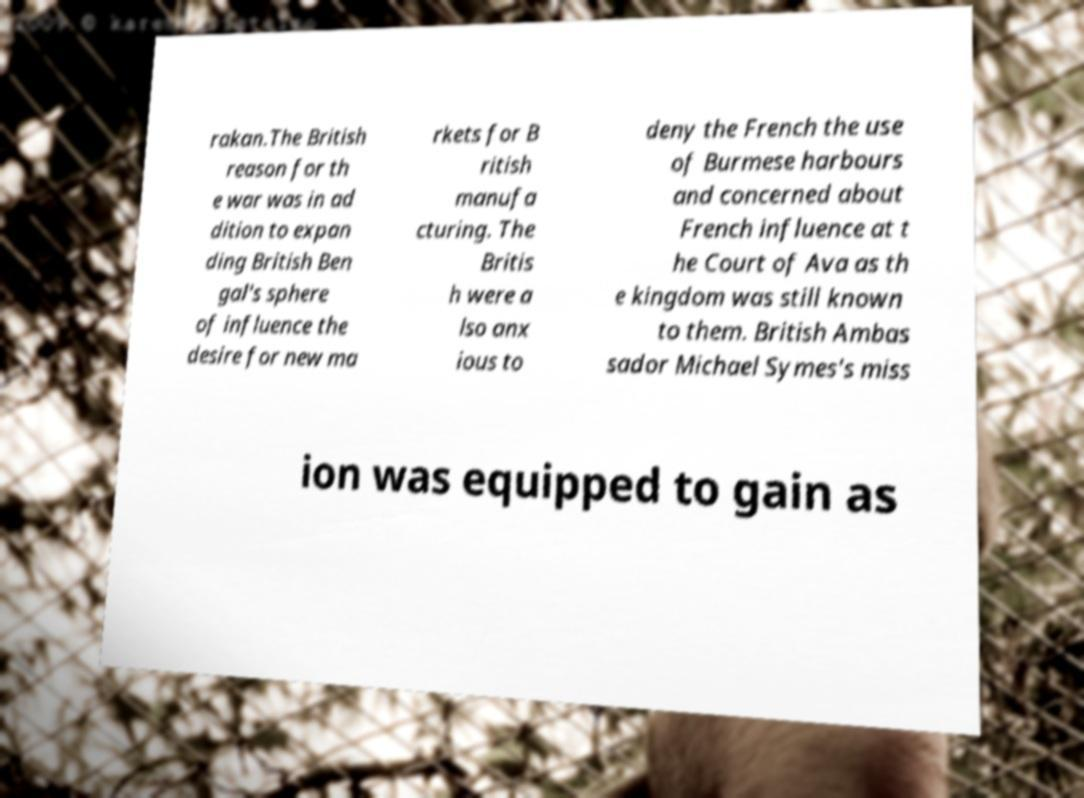What messages or text are displayed in this image? I need them in a readable, typed format. rakan.The British reason for th e war was in ad dition to expan ding British Ben gal's sphere of influence the desire for new ma rkets for B ritish manufa cturing. The Britis h were a lso anx ious to deny the French the use of Burmese harbours and concerned about French influence at t he Court of Ava as th e kingdom was still known to them. British Ambas sador Michael Symes's miss ion was equipped to gain as 